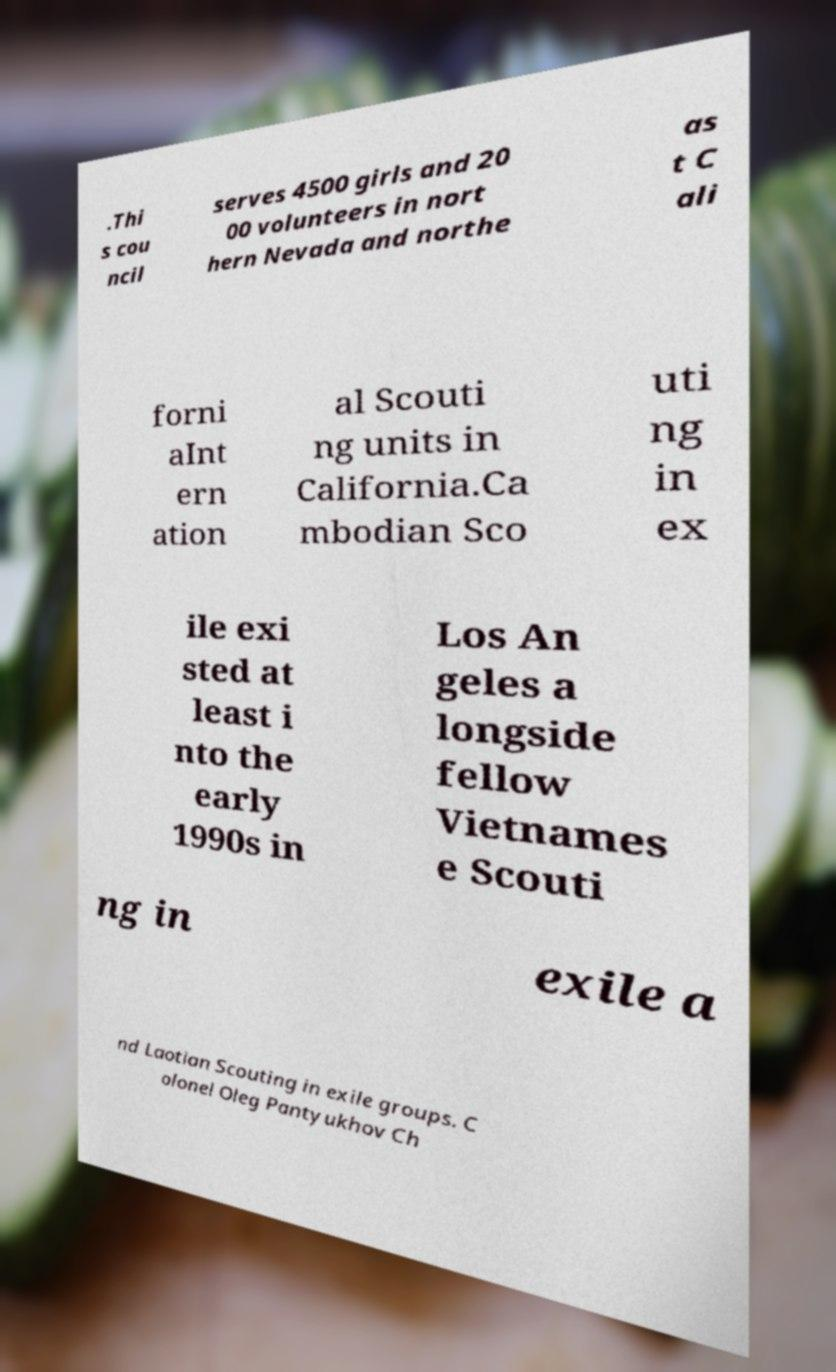Can you accurately transcribe the text from the provided image for me? .Thi s cou ncil serves 4500 girls and 20 00 volunteers in nort hern Nevada and northe as t C ali forni aInt ern ation al Scouti ng units in California.Ca mbodian Sco uti ng in ex ile exi sted at least i nto the early 1990s in Los An geles a longside fellow Vietnames e Scouti ng in exile a nd Laotian Scouting in exile groups. C olonel Oleg Pantyukhov Ch 